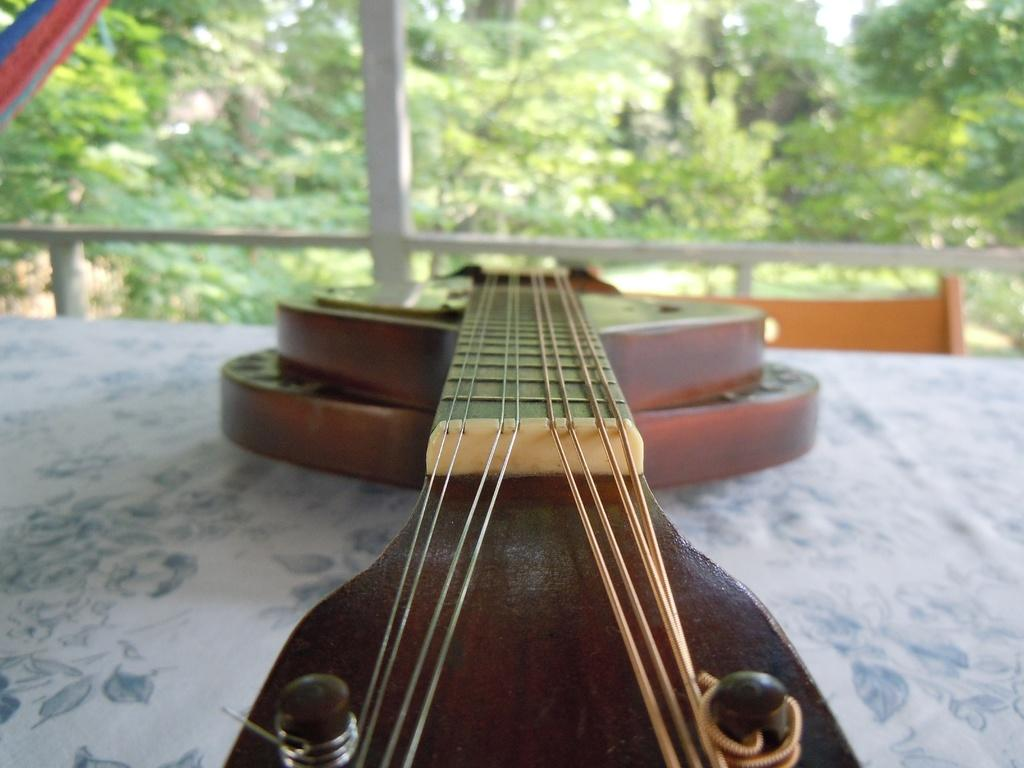What is on the table in the image? There is a guitar on the table in the image. What is covering the table? The table has a white cloth on it. What is in front of the table? There is a chair in front of the table. What can be seen in the background of the image? There are trees in the background of the image. Can you see the twig that the seashore is leaning on in the image? There is no seashore or twig present in the image. 